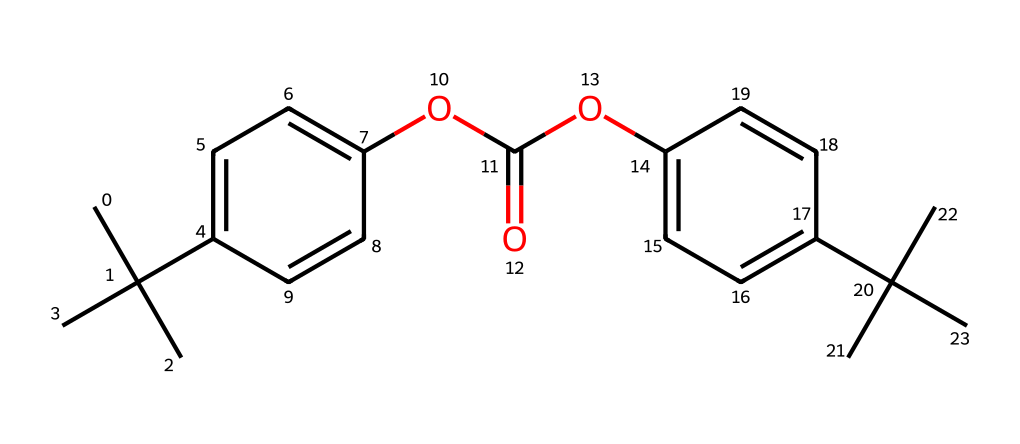What is the main type of polymer represented by this structure? The structure includes repeating units based on the phenolic component with carbonate linkages, indicating it is a polycarbonate polymer.
Answer: polycarbonate How many carbon atoms are present in the structure? By counting the carbon atoms in the chemical structure, there are 20 carbon atoms represented.
Answer: 20 What functional groups are present in this chemical? The structure contains ester (–COO–) functional groups and aromatic rings, indicating its functionalities are associated with polycarbonate properties.
Answer: ester and aromatic What is the role of the aromatic rings in this polymer? The aromatic rings contribute to the rigidity and strength of the polycarbonate by providing stability through resonance and delocalization of electrons.
Answer: rigidity How many oxygen atoms are found in the structure? counting the oxygen atoms present in the given structure indicates there are 4 oxygen atoms in total.
Answer: 4 What characteristic property does the presence of multiple branching alkyl groups confer? The branching alkyl groups promote impact resistance and toughness in the polymer, enhancing its durability in applications like eyeglass lenses and safety goggles.
Answer: impact resistance What might be the effect of the ester linkages on the polymer's thermal properties? The ester linkages in polycarbonate can influence the heat resistance and thermal stability, allowing it to maintain strength at higher temperatures compared to less structured polymers.
Answer: thermal stability 